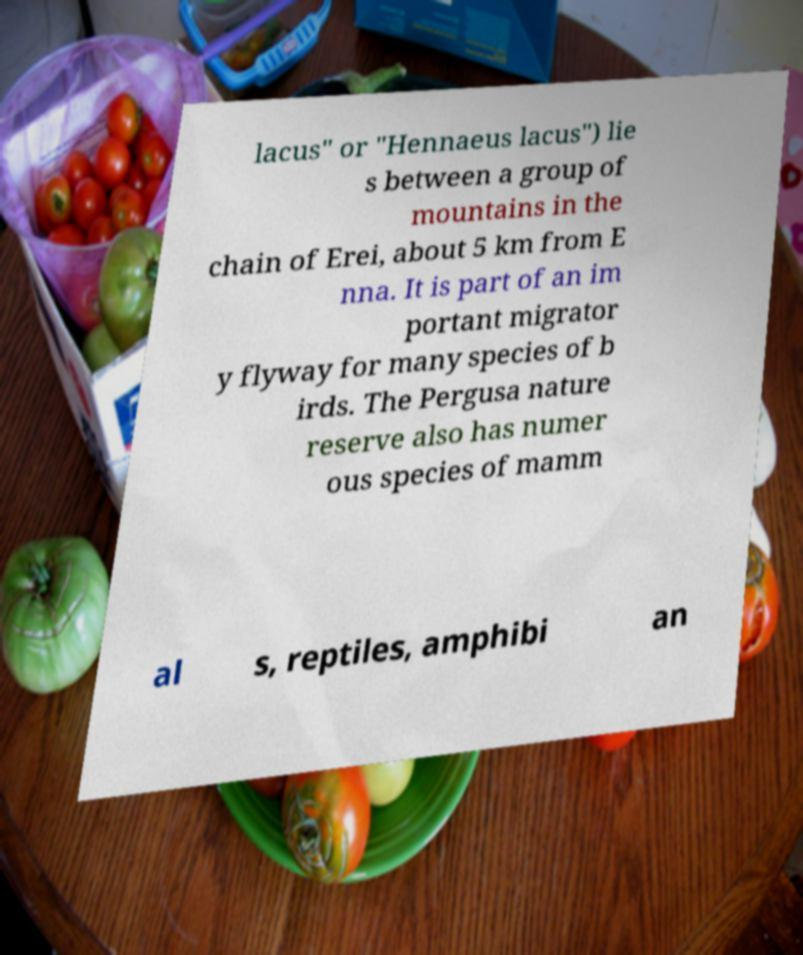I need the written content from this picture converted into text. Can you do that? lacus" or "Hennaeus lacus") lie s between a group of mountains in the chain of Erei, about 5 km from E nna. It is part of an im portant migrator y flyway for many species of b irds. The Pergusa nature reserve also has numer ous species of mamm al s, reptiles, amphibi an 